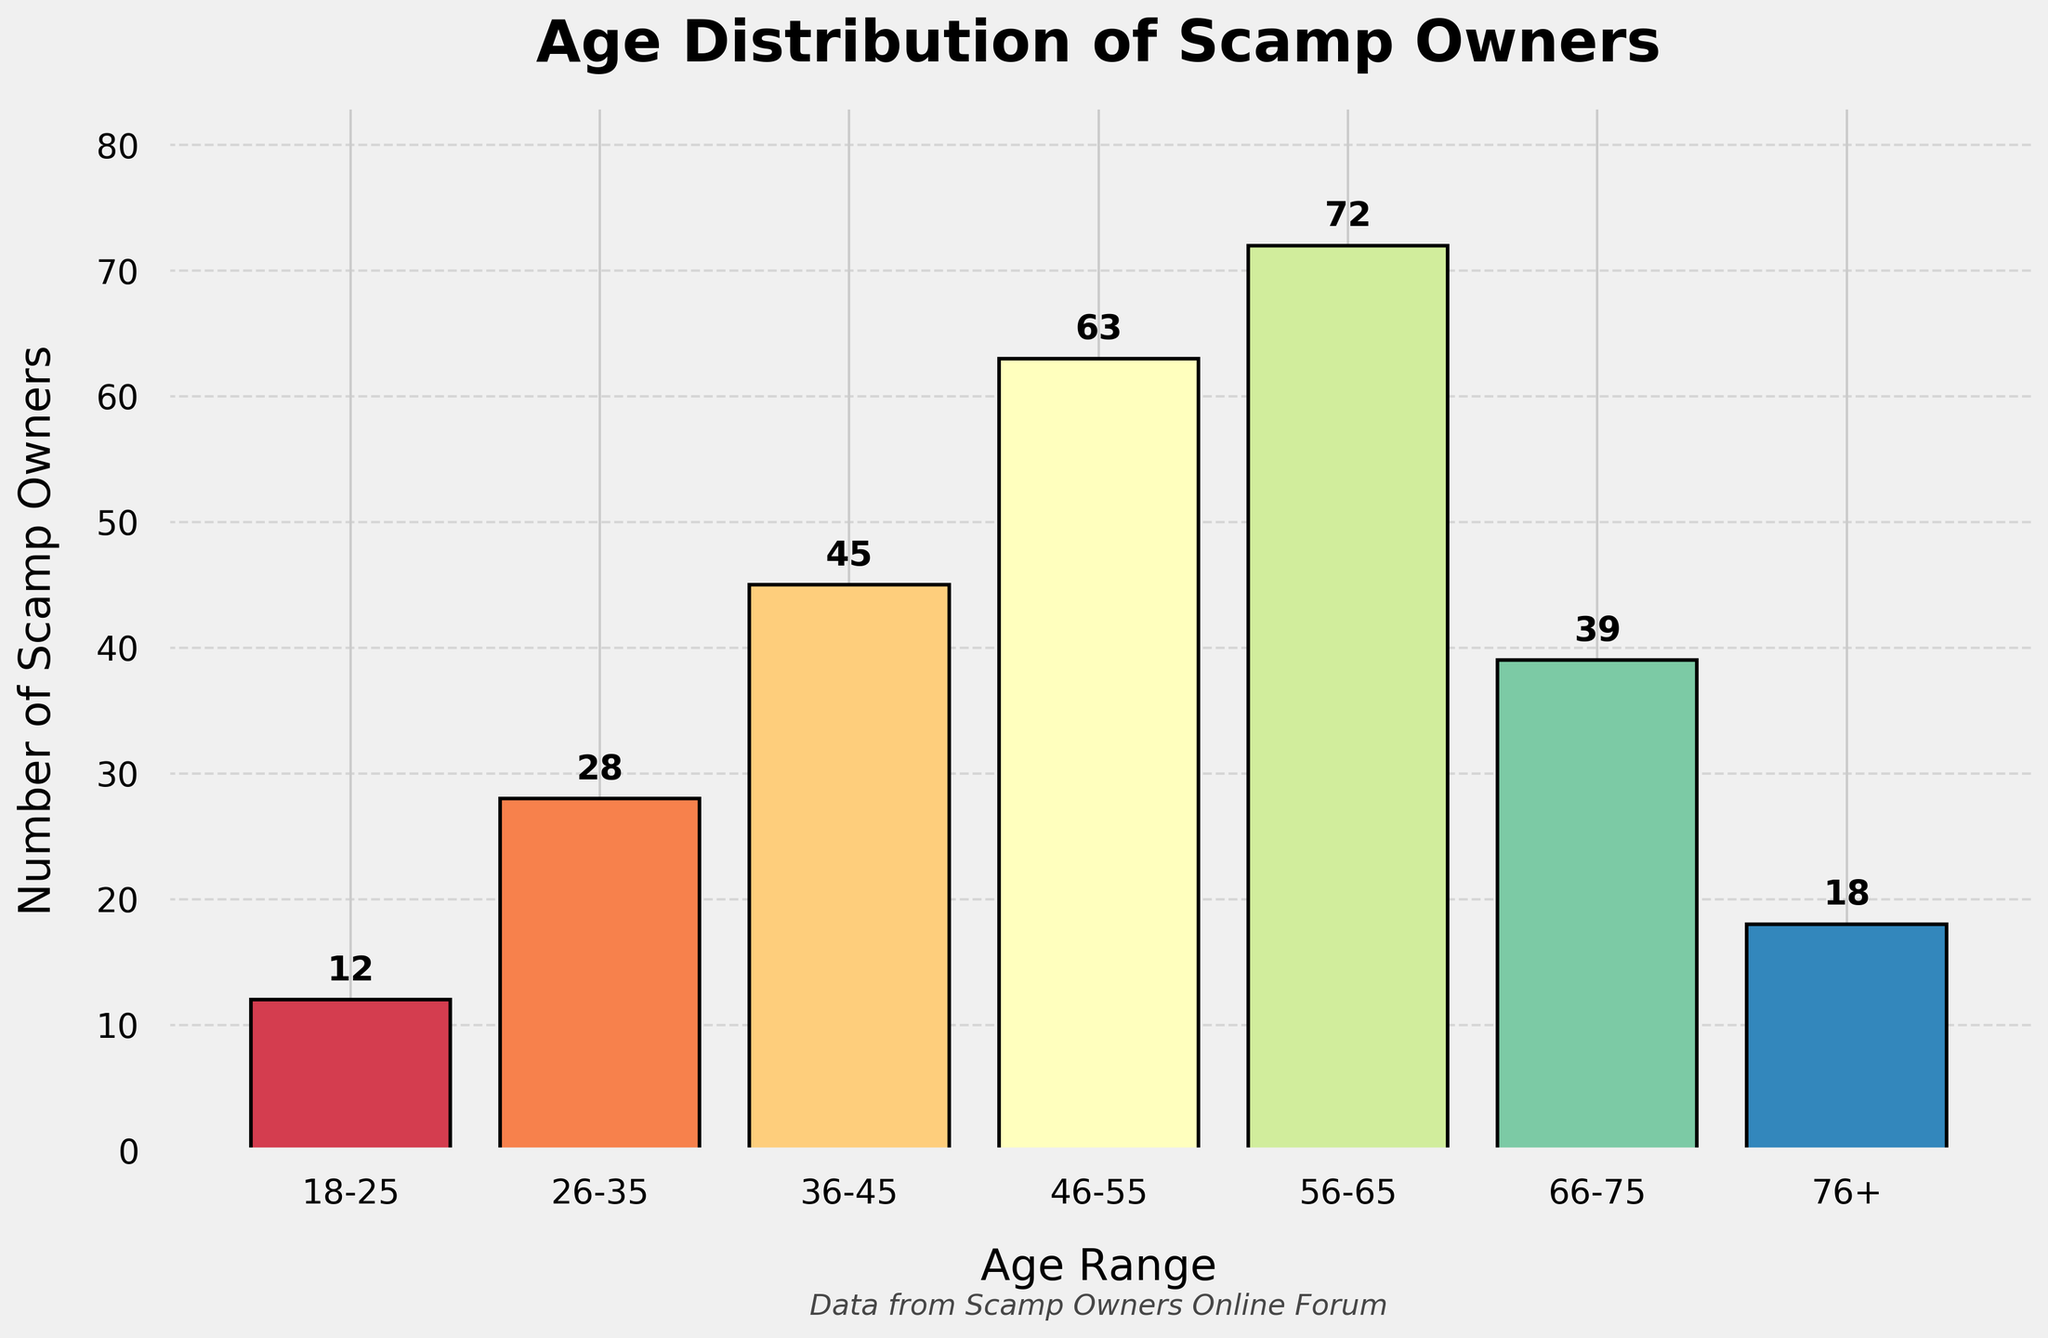what is the title of the histogram? The title is prominently displayed at the top of the chart. Observing the top part of the figure reveals that the title is written in bold.
Answer: Age Distribution of Scamp Owners how many age ranges are represented in the histogram? The age ranges are represented as distinct bars on the x-axis of the histogram. Counting these bars, we find that there are seven distinct age ranges.
Answer: Seven which age range has the highest number of Scamp owners? The height of the bars indicates the number of Scamp owners in each age range. The tallest bar represents the age range with the highest number. Observing the tallest bar, it corresponds to the 56-65 age range.
Answer: 56-65 are there more Scamp owners between ages 18-25 or 76+? To determine which age group has more owners, compare the heights of the bars for the 18-25 and 76+ age ranges. The bar for 18-25 is taller than the one for 76+, indicating more owners.
Answer: 18-25 how many Scamp owners are there in age ranges 26-35 and 36-45 combined? To find the total number of Scamp owners in both age ranges, add the numbers from the two bars. For 26-35, there are 28 owners, and for 36-45, there are 45 owners, so 28 + 45 = 73.
Answer: 73 what is the average number of Scamp owners across all age ranges? Calculate the average by summing the number of owners in all age ranges and then dividing by the number of age ranges. The numbers are 12, 28, 45, 63, 72, 39, and 18. The sum is 277, and there are seven age ranges, so 277/7 ≈ 39.57.
Answer: 39.57 which age range has fewer owners: 46-55 or 66-75? To determine which age range has fewer owners, compare the heights of the respective bars. Count the owners in each group: 63 for 46-55 and 39 for 66-75. Hence, 66-75 has fewer owners.
Answer: 66-75 is there a trend in the number of Scamp owners as age increases? Observing the bars from left to right, there is an increase in the number of owners until the 56-65 age range, after which the numbers decrease.
Answer: Increase then decrease what is the difference in the number of Scamp owners between the age ranges 36-45 and 18-25? Determine the number of owners in each range and subtract the smaller number from the larger number. 45 owners in 36-45 and 12 owners in 18-25, so the difference is 45 - 12 = 33.
Answer: 33 how many more owners are there in the age range 56-65 compared to 26-35? Subtract the number of owners in 26-35 from the number in 56-65. There are 72 owners in 56-65 and 28 in 26-35, so 72 - 28 = 44.
Answer: 44 